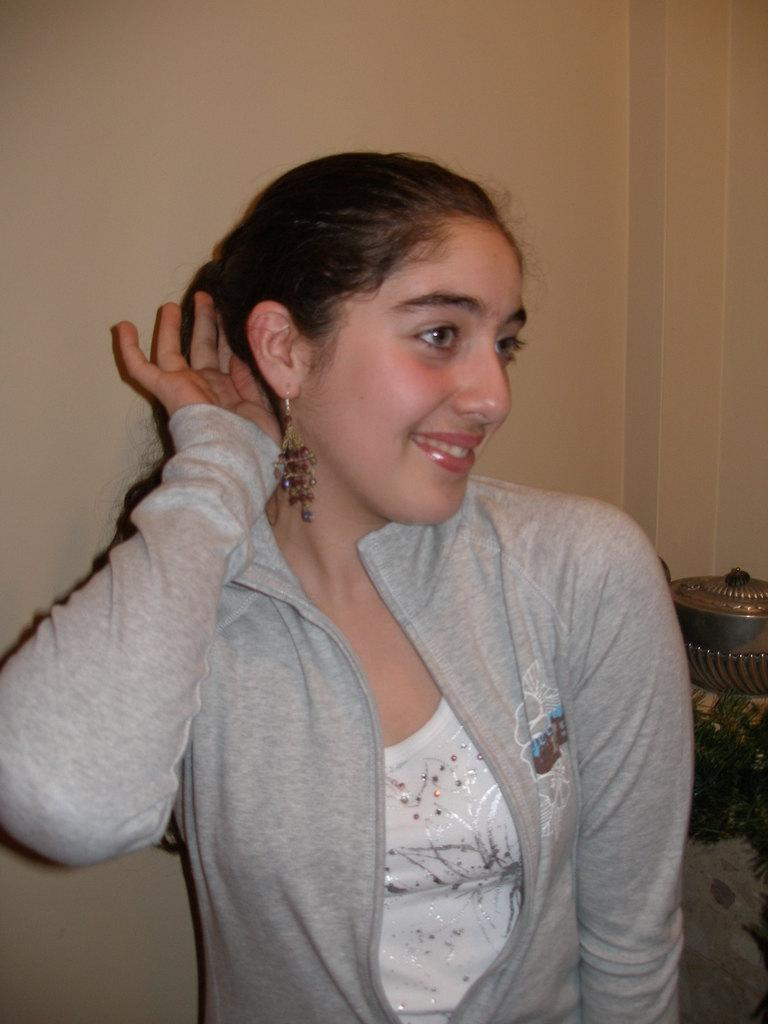Who is present in the image? There is a woman in the image. What can be seen on the opposite side of the image? Objects are visible on the backside of the image. What type of structure is in the image? There is a wall in the image. What type of punishment is the woman receiving in the image? There is no indication of punishment in the image; the woman is simply present. Can you see a tiger or duck in the image? No, there are no tigers or ducks present in the image. 